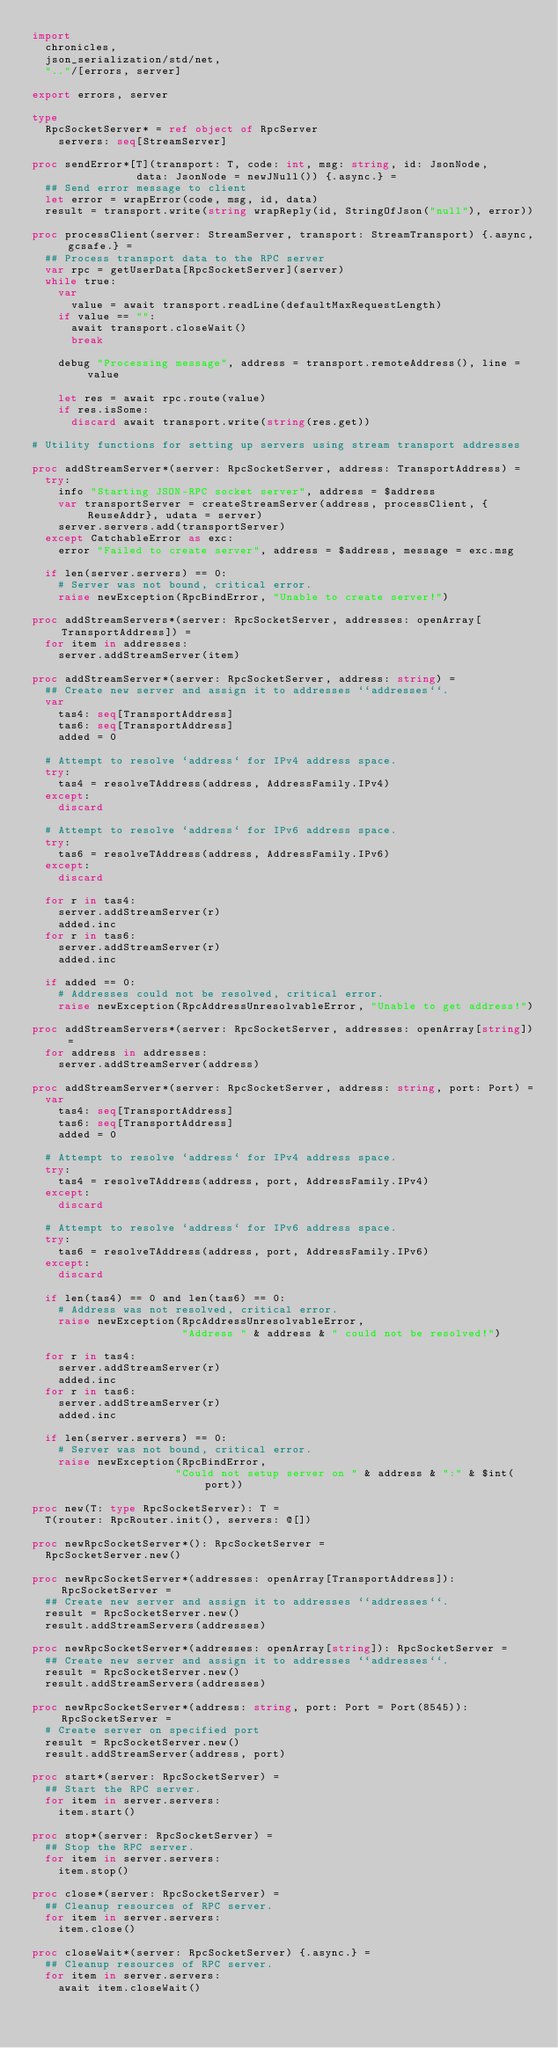<code> <loc_0><loc_0><loc_500><loc_500><_Nim_>import
  chronicles,
  json_serialization/std/net,
  ".."/[errors, server]

export errors, server

type
  RpcSocketServer* = ref object of RpcServer
    servers: seq[StreamServer]

proc sendError*[T](transport: T, code: int, msg: string, id: JsonNode,
                data: JsonNode = newJNull()) {.async.} =
  ## Send error message to client
  let error = wrapError(code, msg, id, data)
  result = transport.write(string wrapReply(id, StringOfJson("null"), error))

proc processClient(server: StreamServer, transport: StreamTransport) {.async, gcsafe.} =
  ## Process transport data to the RPC server
  var rpc = getUserData[RpcSocketServer](server)
  while true:
    var
      value = await transport.readLine(defaultMaxRequestLength)
    if value == "":
      await transport.closeWait()
      break

    debug "Processing message", address = transport.remoteAddress(), line = value

    let res = await rpc.route(value)
    if res.isSome:
      discard await transport.write(string(res.get))

# Utility functions for setting up servers using stream transport addresses

proc addStreamServer*(server: RpcSocketServer, address: TransportAddress) =
  try:
    info "Starting JSON-RPC socket server", address = $address
    var transportServer = createStreamServer(address, processClient, {ReuseAddr}, udata = server)
    server.servers.add(transportServer)
  except CatchableError as exc:
    error "Failed to create server", address = $address, message = exc.msg

  if len(server.servers) == 0:
    # Server was not bound, critical error.
    raise newException(RpcBindError, "Unable to create server!")

proc addStreamServers*(server: RpcSocketServer, addresses: openArray[TransportAddress]) =
  for item in addresses:
    server.addStreamServer(item)

proc addStreamServer*(server: RpcSocketServer, address: string) =
  ## Create new server and assign it to addresses ``addresses``.
  var
    tas4: seq[TransportAddress]
    tas6: seq[TransportAddress]
    added = 0

  # Attempt to resolve `address` for IPv4 address space.
  try:
    tas4 = resolveTAddress(address, AddressFamily.IPv4)
  except:
    discard

  # Attempt to resolve `address` for IPv6 address space.
  try:
    tas6 = resolveTAddress(address, AddressFamily.IPv6)
  except:
    discard

  for r in tas4:
    server.addStreamServer(r)
    added.inc
  for r in tas6:
    server.addStreamServer(r)
    added.inc

  if added == 0:
    # Addresses could not be resolved, critical error.
    raise newException(RpcAddressUnresolvableError, "Unable to get address!")

proc addStreamServers*(server: RpcSocketServer, addresses: openArray[string]) =
  for address in addresses:
    server.addStreamServer(address)

proc addStreamServer*(server: RpcSocketServer, address: string, port: Port) =
  var
    tas4: seq[TransportAddress]
    tas6: seq[TransportAddress]
    added = 0

  # Attempt to resolve `address` for IPv4 address space.
  try:
    tas4 = resolveTAddress(address, port, AddressFamily.IPv4)
  except:
    discard

  # Attempt to resolve `address` for IPv6 address space.
  try:
    tas6 = resolveTAddress(address, port, AddressFamily.IPv6)
  except:
    discard

  if len(tas4) == 0 and len(tas6) == 0:
    # Address was not resolved, critical error.
    raise newException(RpcAddressUnresolvableError,
                       "Address " & address & " could not be resolved!")

  for r in tas4:
    server.addStreamServer(r)
    added.inc
  for r in tas6:
    server.addStreamServer(r)
    added.inc

  if len(server.servers) == 0:
    # Server was not bound, critical error.
    raise newException(RpcBindError,
                      "Could not setup server on " & address & ":" & $int(port))

proc new(T: type RpcSocketServer): T =
  T(router: RpcRouter.init(), servers: @[])

proc newRpcSocketServer*(): RpcSocketServer =
  RpcSocketServer.new()

proc newRpcSocketServer*(addresses: openArray[TransportAddress]): RpcSocketServer =
  ## Create new server and assign it to addresses ``addresses``.
  result = RpcSocketServer.new()
  result.addStreamServers(addresses)

proc newRpcSocketServer*(addresses: openArray[string]): RpcSocketServer =
  ## Create new server and assign it to addresses ``addresses``.
  result = RpcSocketServer.new()
  result.addStreamServers(addresses)

proc newRpcSocketServer*(address: string, port: Port = Port(8545)): RpcSocketServer =
  # Create server on specified port
  result = RpcSocketServer.new()
  result.addStreamServer(address, port)

proc start*(server: RpcSocketServer) =
  ## Start the RPC server.
  for item in server.servers:
    item.start()

proc stop*(server: RpcSocketServer) =
  ## Stop the RPC server.
  for item in server.servers:
    item.stop()

proc close*(server: RpcSocketServer) =
  ## Cleanup resources of RPC server.
  for item in server.servers:
    item.close()

proc closeWait*(server: RpcSocketServer) {.async.} =
  ## Cleanup resources of RPC server.
  for item in server.servers:
    await item.closeWait()
</code> 